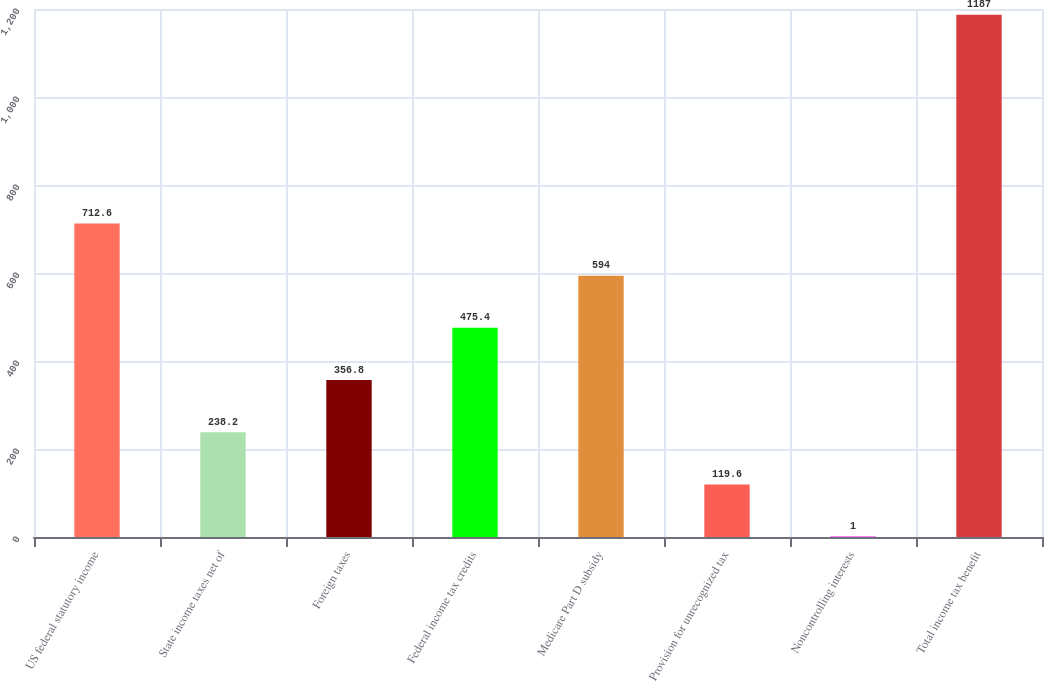Convert chart. <chart><loc_0><loc_0><loc_500><loc_500><bar_chart><fcel>US federal statutory income<fcel>State income taxes net of<fcel>Foreign taxes<fcel>Federal income tax credits<fcel>Medicare Part D subsidy<fcel>Provision for unrecognized tax<fcel>Noncontrolling interests<fcel>Total income tax benefit<nl><fcel>712.6<fcel>238.2<fcel>356.8<fcel>475.4<fcel>594<fcel>119.6<fcel>1<fcel>1187<nl></chart> 